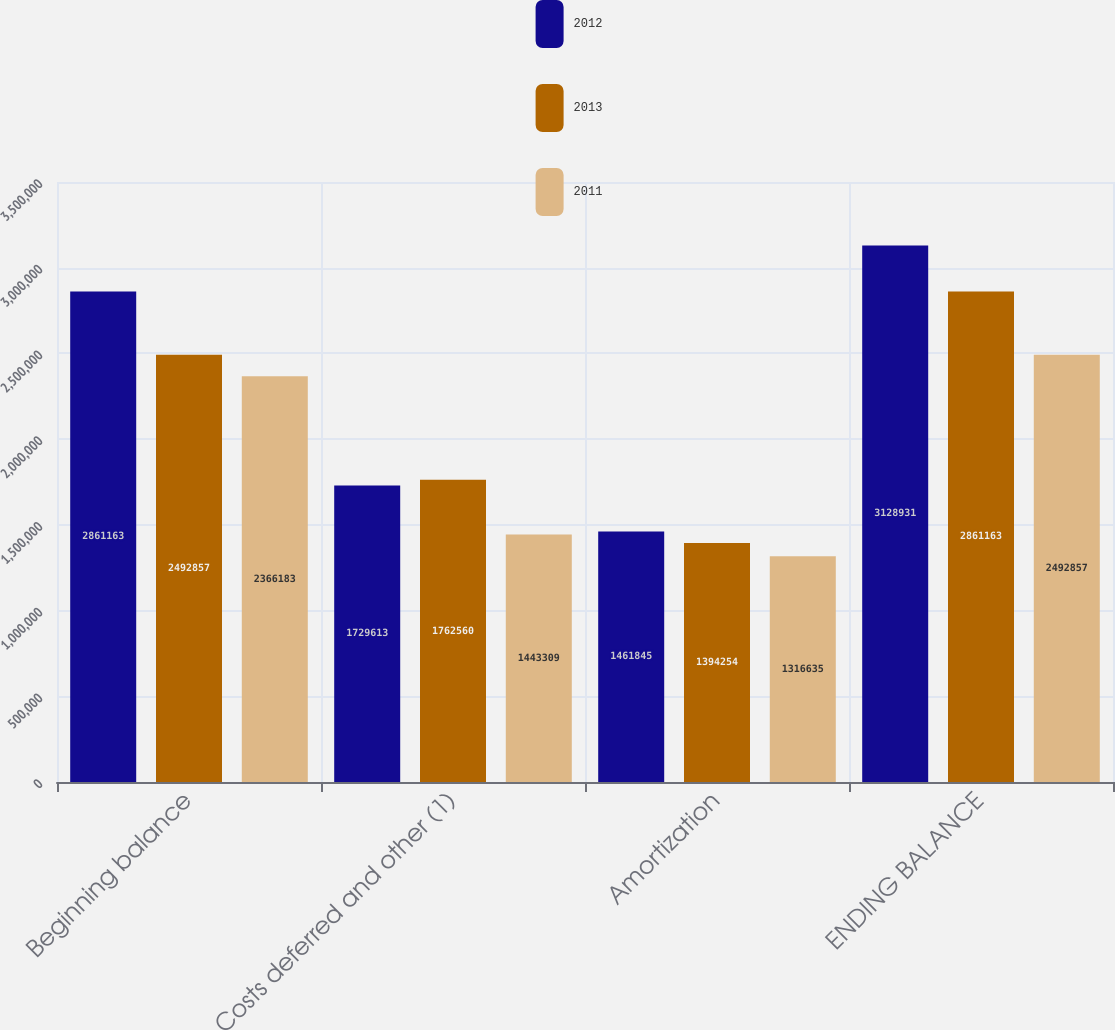Convert chart. <chart><loc_0><loc_0><loc_500><loc_500><stacked_bar_chart><ecel><fcel>Beginning balance<fcel>Costs deferred and other (1)<fcel>Amortization<fcel>ENDING BALANCE<nl><fcel>2012<fcel>2.86116e+06<fcel>1.72961e+06<fcel>1.46184e+06<fcel>3.12893e+06<nl><fcel>2013<fcel>2.49286e+06<fcel>1.76256e+06<fcel>1.39425e+06<fcel>2.86116e+06<nl><fcel>2011<fcel>2.36618e+06<fcel>1.44331e+06<fcel>1.31664e+06<fcel>2.49286e+06<nl></chart> 